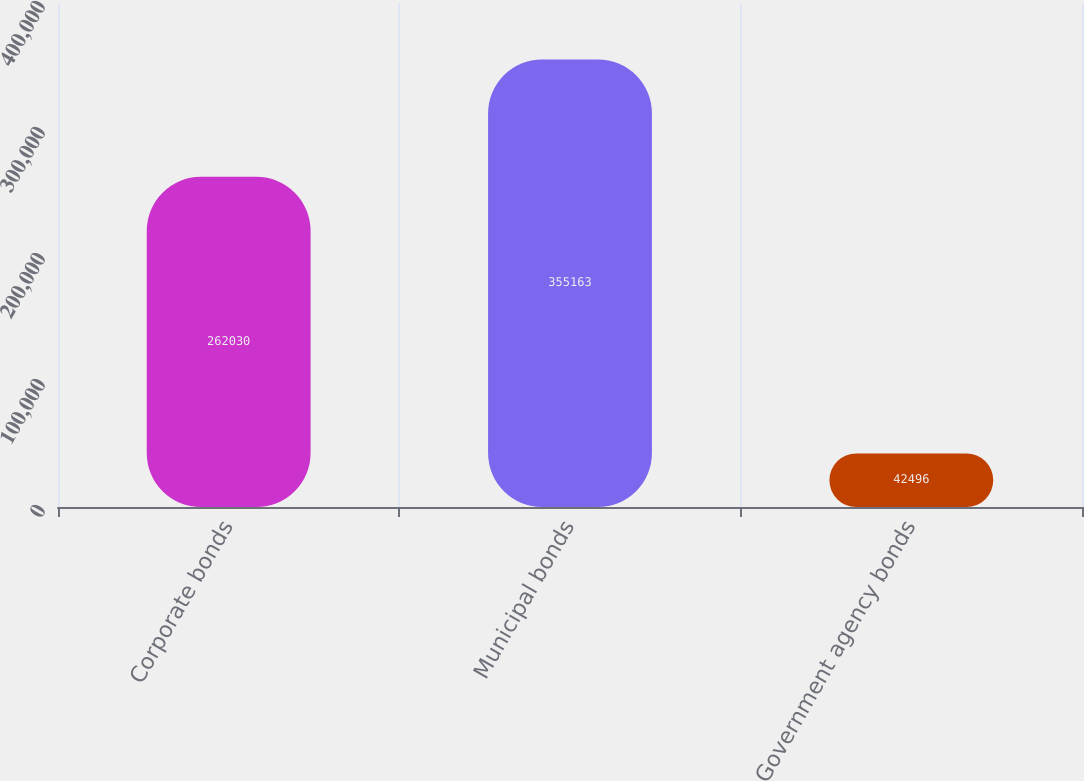Convert chart. <chart><loc_0><loc_0><loc_500><loc_500><bar_chart><fcel>Corporate bonds<fcel>Municipal bonds<fcel>Government agency bonds<nl><fcel>262030<fcel>355163<fcel>42496<nl></chart> 